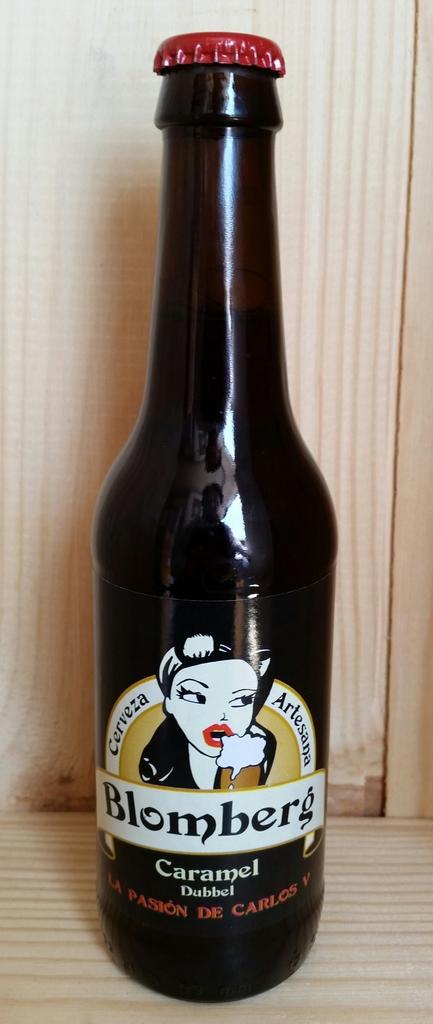What flavor of beer is in the bottle?
Your response must be concise. Caramel. 